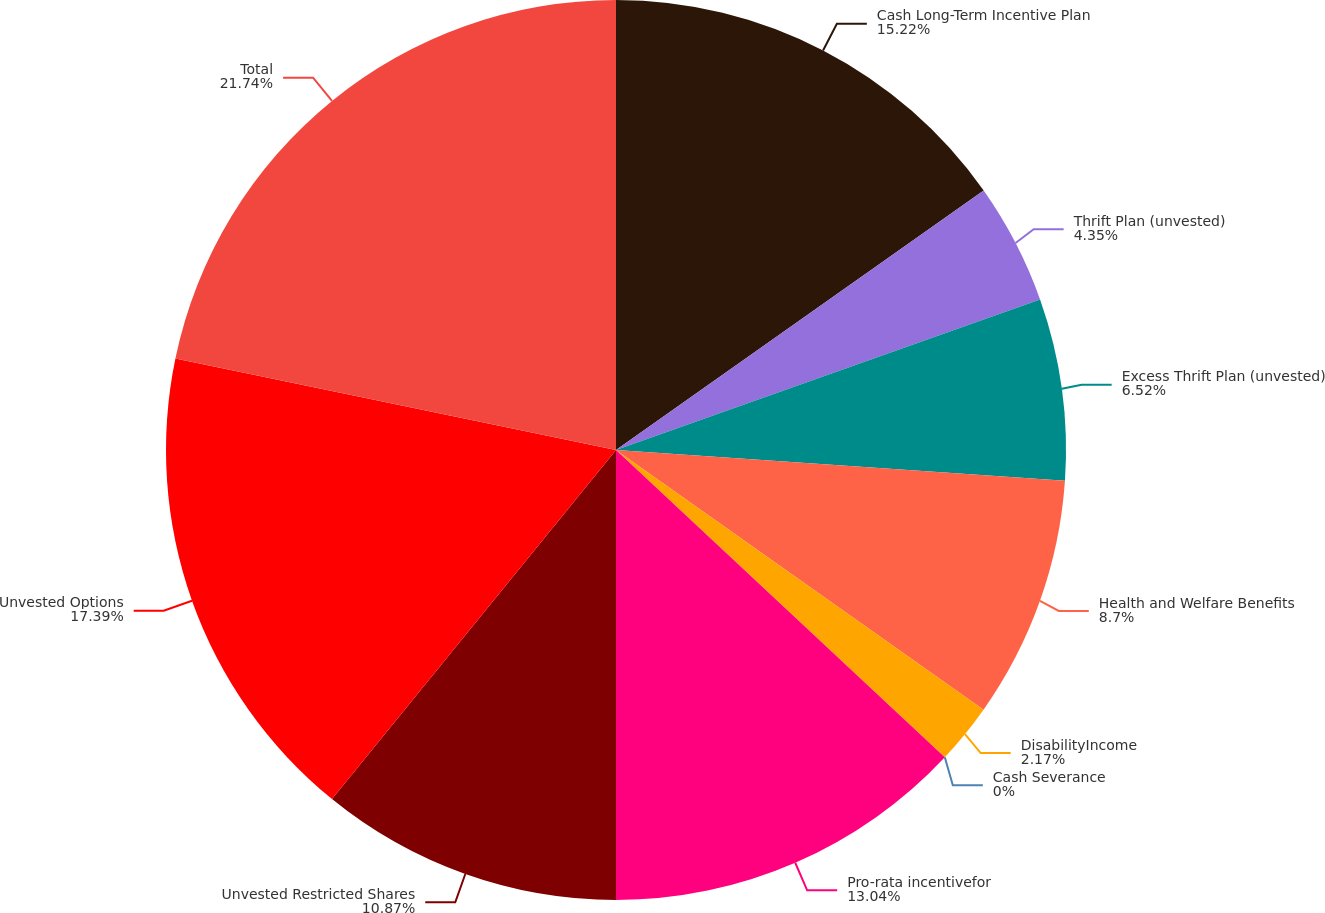Convert chart to OTSL. <chart><loc_0><loc_0><loc_500><loc_500><pie_chart><fcel>Cash Long-Term Incentive Plan<fcel>Thrift Plan (unvested)<fcel>Excess Thrift Plan (unvested)<fcel>Health and Welfare Benefits<fcel>DisabilityIncome<fcel>Cash Severance<fcel>Pro-rata incentivefor<fcel>Unvested Restricted Shares<fcel>Unvested Options<fcel>Total<nl><fcel>15.22%<fcel>4.35%<fcel>6.52%<fcel>8.7%<fcel>2.17%<fcel>0.0%<fcel>13.04%<fcel>10.87%<fcel>17.39%<fcel>21.74%<nl></chart> 